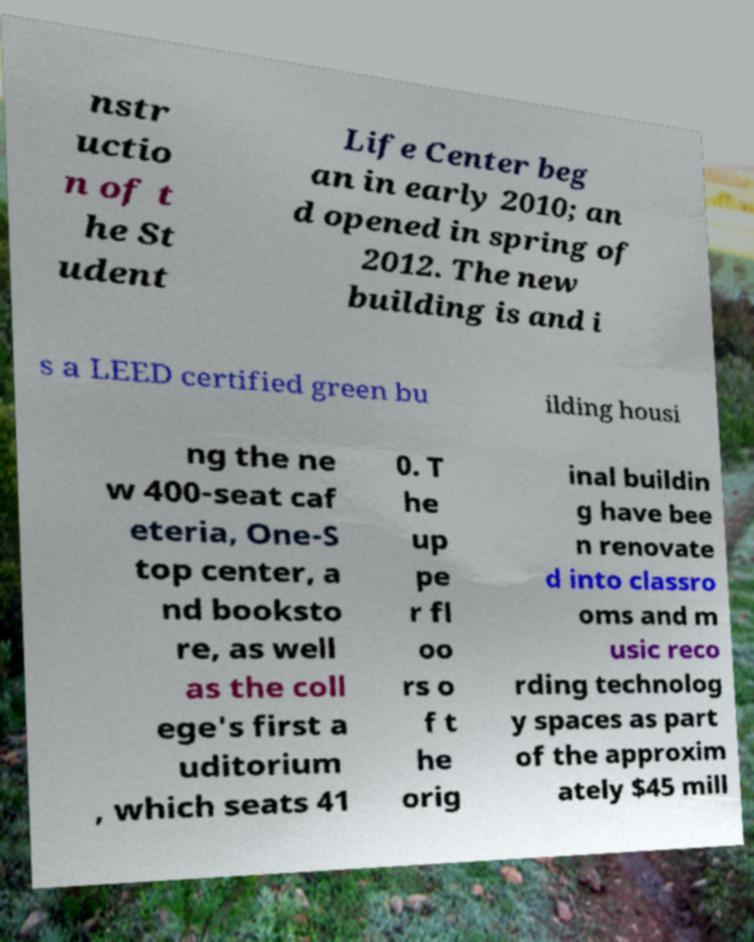What messages or text are displayed in this image? I need them in a readable, typed format. nstr uctio n of t he St udent Life Center beg an in early 2010; an d opened in spring of 2012. The new building is and i s a LEED certified green bu ilding housi ng the ne w 400-seat caf eteria, One-S top center, a nd booksto re, as well as the coll ege's first a uditorium , which seats 41 0. T he up pe r fl oo rs o f t he orig inal buildin g have bee n renovate d into classro oms and m usic reco rding technolog y spaces as part of the approxim ately $45 mill 